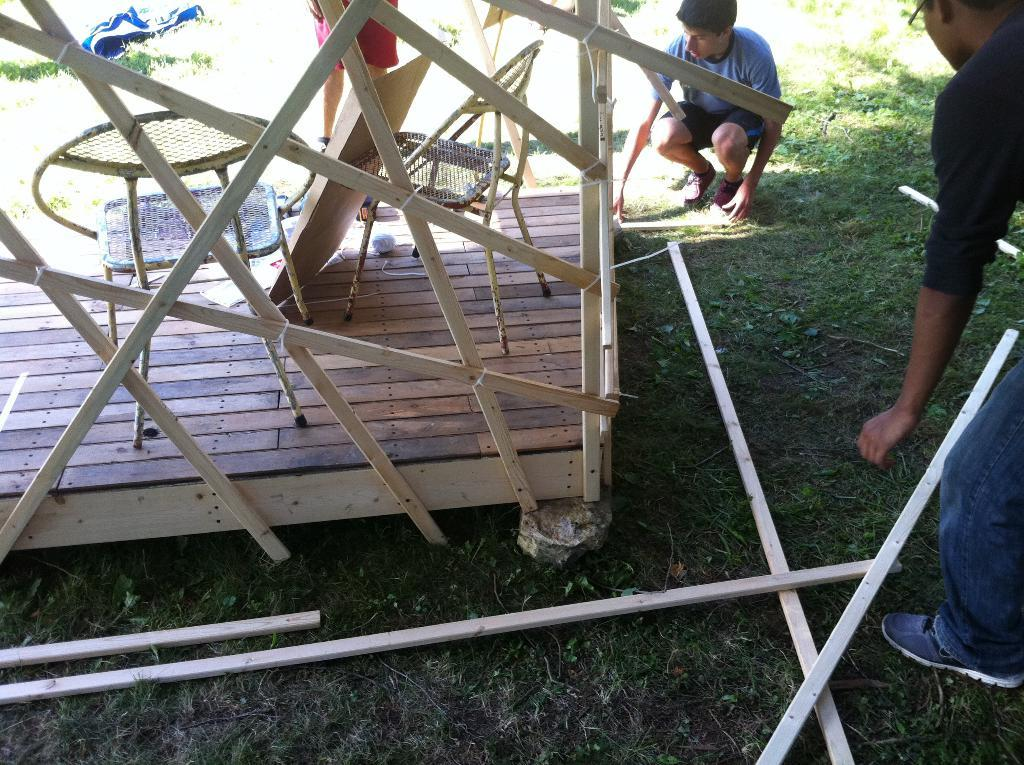What type of furniture is present in the image? There are chairs in the image. What is placed on the wooden platform? There is a cardboard on a wooden platform in the image. How many people are in the image? There are three persons in the image. What can be seen on the ground in the image? There are wooden sticks on the ground in the image. What type of bubble is being blown by the person in the image? There is no bubble present in the image. What is the plot of the story being told in the image? The image does not depict a story or plot. 